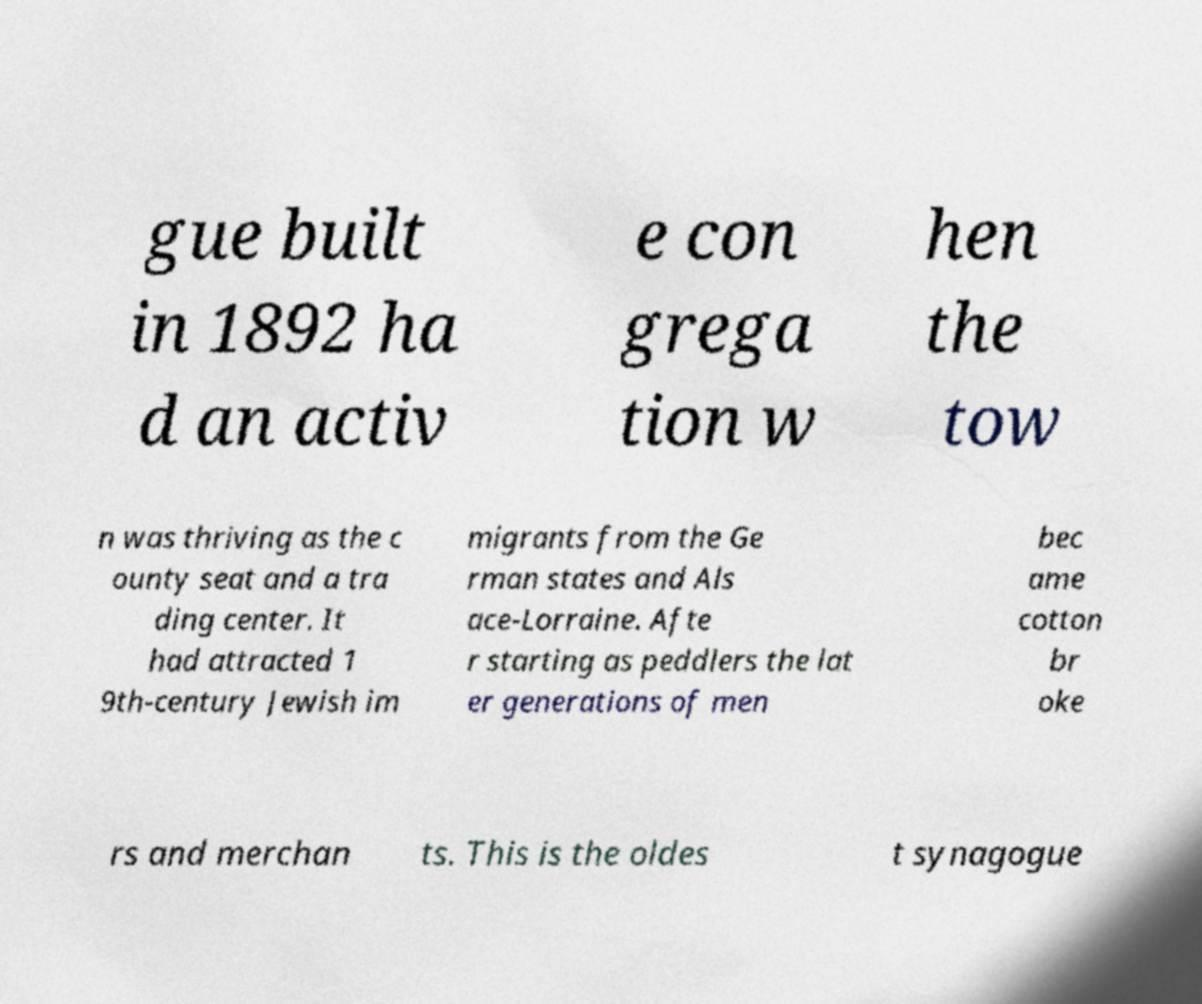Please read and relay the text visible in this image. What does it say? gue built in 1892 ha d an activ e con grega tion w hen the tow n was thriving as the c ounty seat and a tra ding center. It had attracted 1 9th-century Jewish im migrants from the Ge rman states and Als ace-Lorraine. Afte r starting as peddlers the lat er generations of men bec ame cotton br oke rs and merchan ts. This is the oldes t synagogue 